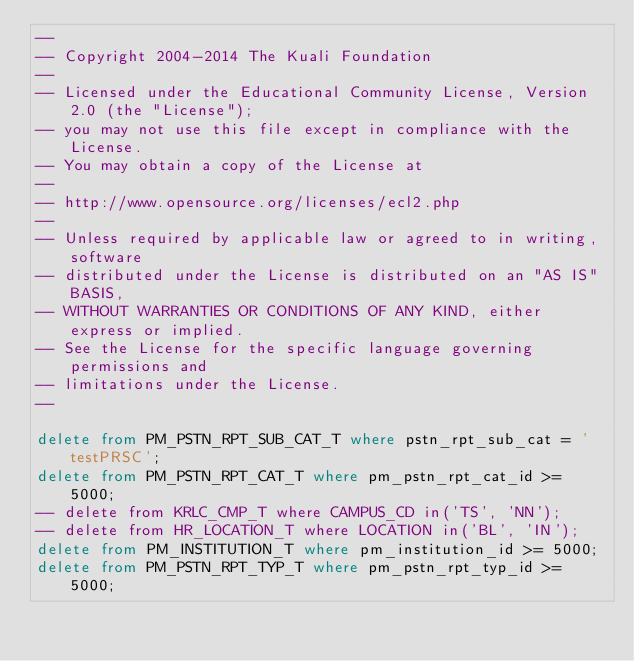Convert code to text. <code><loc_0><loc_0><loc_500><loc_500><_SQL_>--
-- Copyright 2004-2014 The Kuali Foundation
--
-- Licensed under the Educational Community License, Version 2.0 (the "License");
-- you may not use this file except in compliance with the License.
-- You may obtain a copy of the License at
--
-- http://www.opensource.org/licenses/ecl2.php
--
-- Unless required by applicable law or agreed to in writing, software
-- distributed under the License is distributed on an "AS IS" BASIS,
-- WITHOUT WARRANTIES OR CONDITIONS OF ANY KIND, either express or implied.
-- See the License for the specific language governing permissions and
-- limitations under the License.
--

delete from PM_PSTN_RPT_SUB_CAT_T where pstn_rpt_sub_cat = 'testPRSC';
delete from PM_PSTN_RPT_CAT_T where pm_pstn_rpt_cat_id >= 5000;
-- delete from KRLC_CMP_T where CAMPUS_CD in('TS', 'NN');
-- delete from HR_LOCATION_T where LOCATION in('BL', 'IN');
delete from PM_INSTITUTION_T where pm_institution_id >= 5000;
delete from PM_PSTN_RPT_TYP_T where pm_pstn_rpt_typ_id >= 5000;</code> 